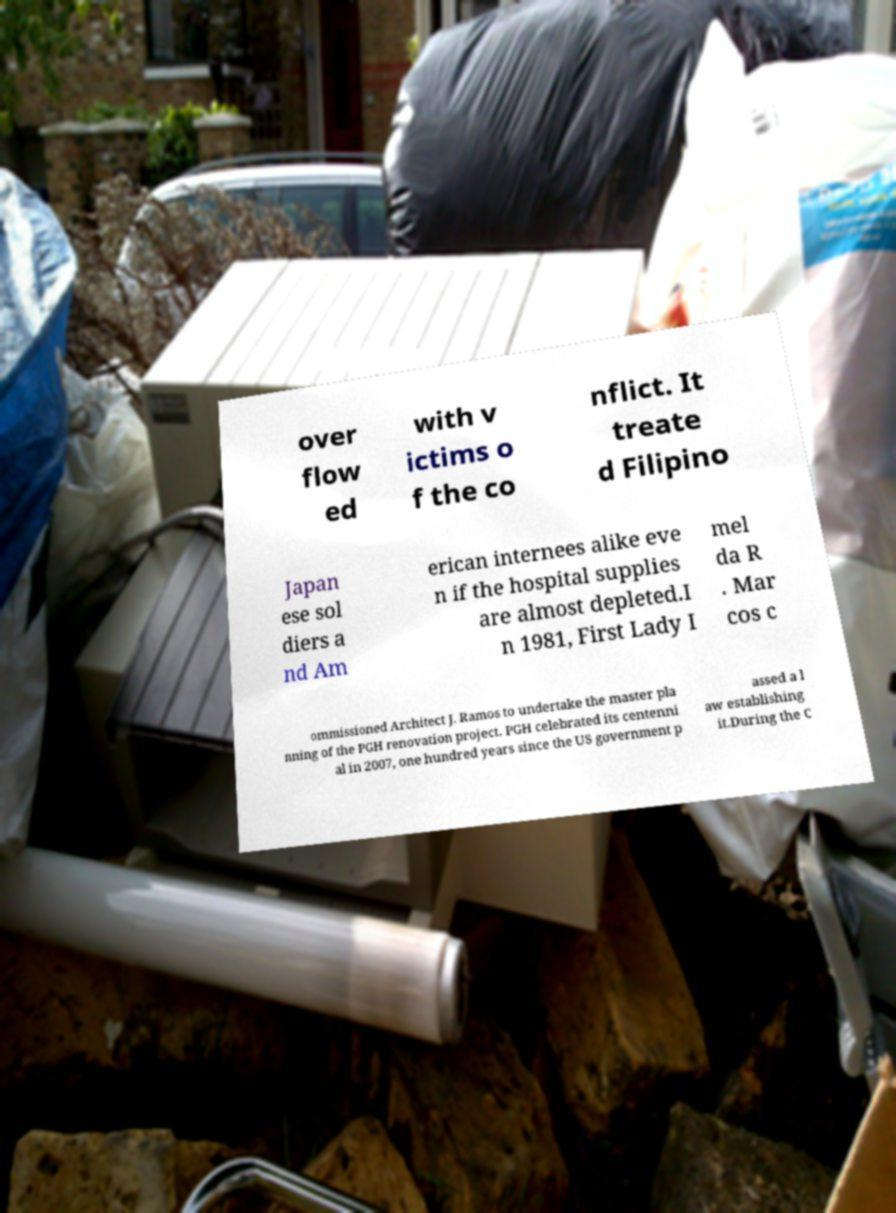Please read and relay the text visible in this image. What does it say? over flow ed with v ictims o f the co nflict. It treate d Filipino Japan ese sol diers a nd Am erican internees alike eve n if the hospital supplies are almost depleted.I n 1981, First Lady I mel da R . Mar cos c ommissioned Architect J. Ramos to undertake the master pla nning of the PGH renovation project. PGH celebrated its centenni al in 2007, one hundred years since the US government p assed a l aw establishing it.During the C 